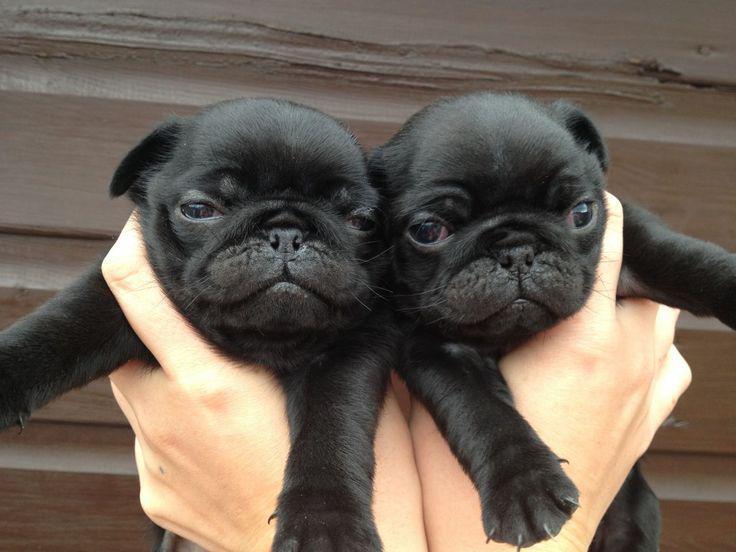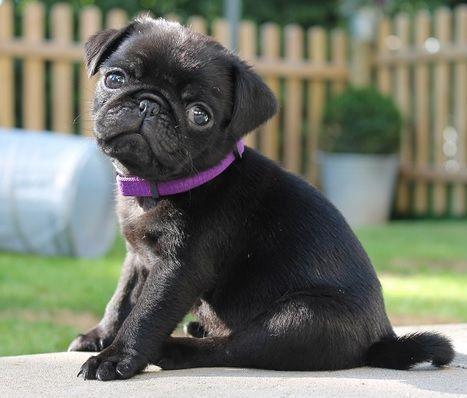The first image is the image on the left, the second image is the image on the right. For the images displayed, is the sentence "Two dogs are sitting in the grass in one of the images." factually correct? Answer yes or no. No. The first image is the image on the left, the second image is the image on the right. For the images shown, is this caption "There are exactly two dogs on the grass in the image on the right." true? Answer yes or no. No. 